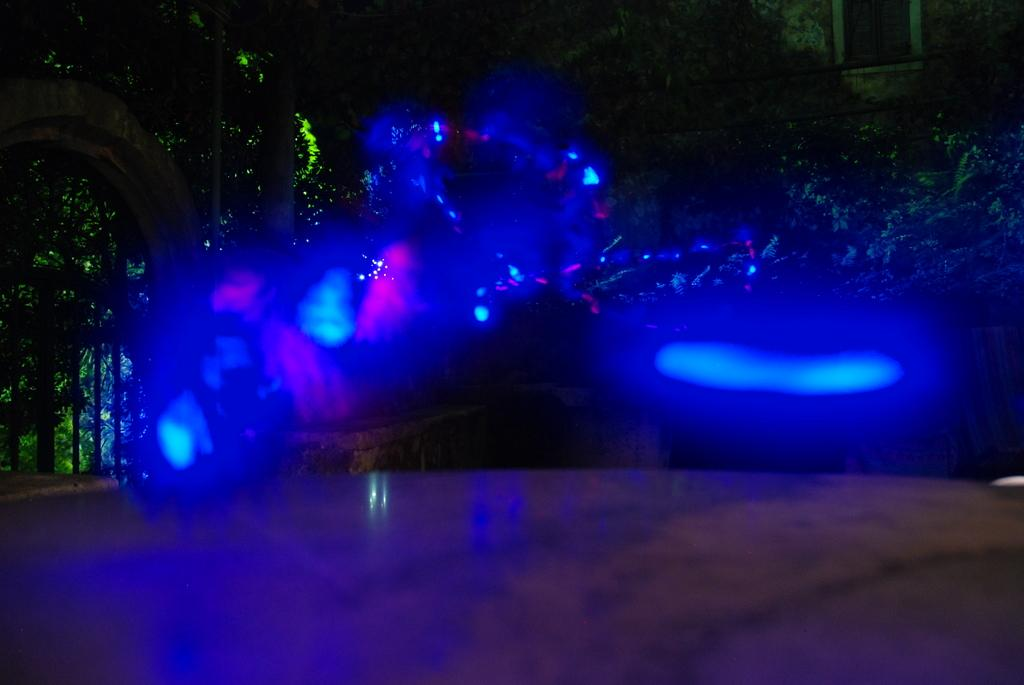What type of lighting is used in the image? There are blue lights arranged in the image. What can be seen in the background of the image? There are plants and trees in the backdrop of the image. What type of structure is visible in the image? There is a house visible in the image. What type of spy equipment can be seen in the image? There is no spy equipment present in the image. How much cream is visible in the image? There is no cream present in the image. 